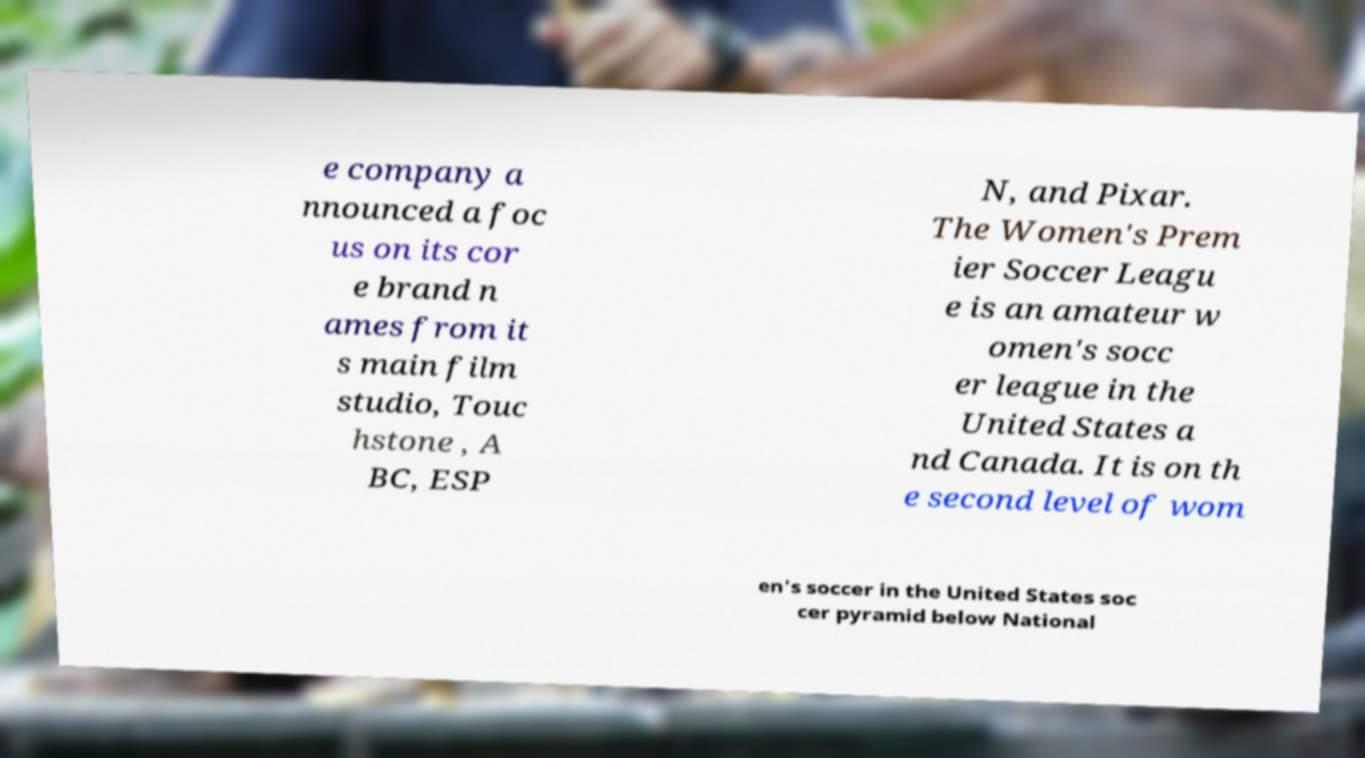There's text embedded in this image that I need extracted. Can you transcribe it verbatim? e company a nnounced a foc us on its cor e brand n ames from it s main film studio, Touc hstone , A BC, ESP N, and Pixar. The Women's Prem ier Soccer Leagu e is an amateur w omen's socc er league in the United States a nd Canada. It is on th e second level of wom en's soccer in the United States soc cer pyramid below National 